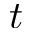Convert formula to latex. <formula><loc_0><loc_0><loc_500><loc_500>t</formula> 